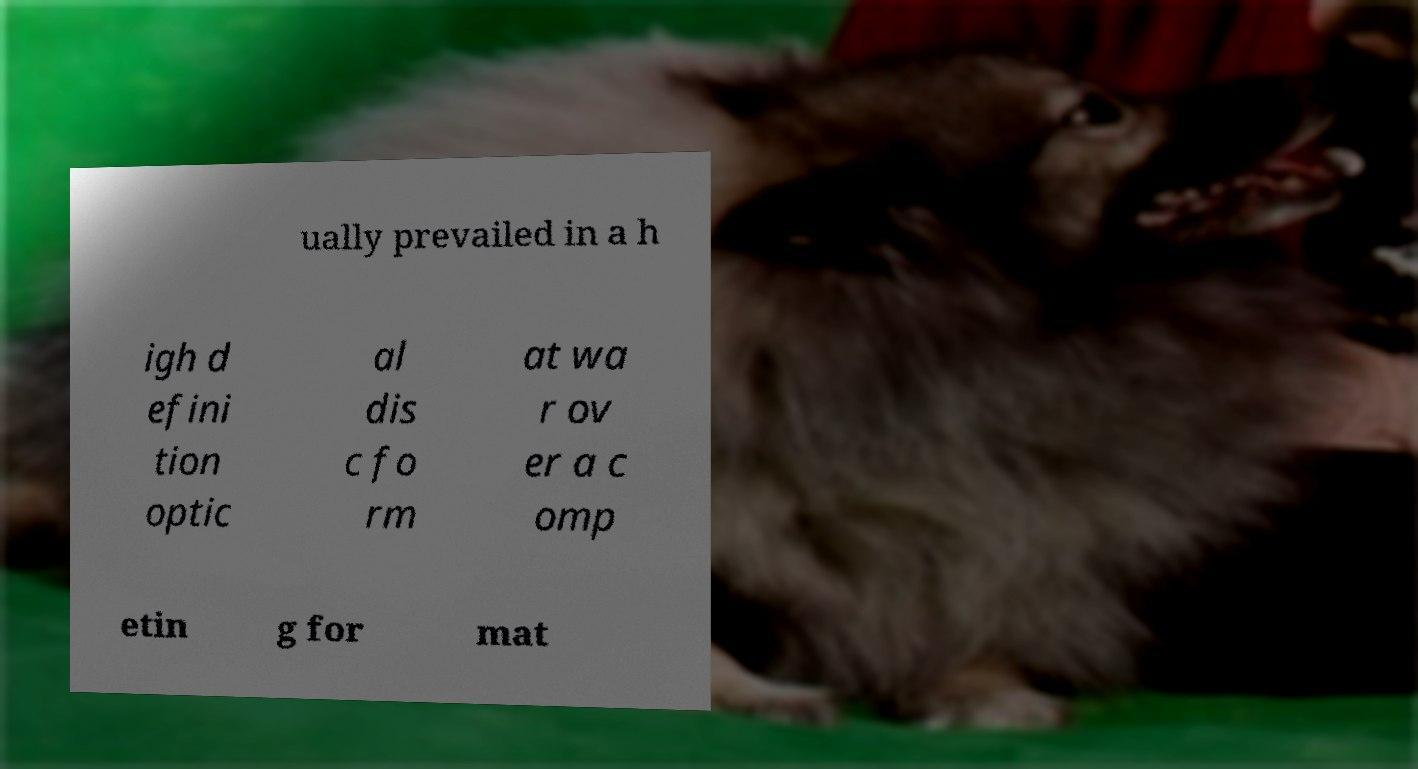Please read and relay the text visible in this image. What does it say? ually prevailed in a h igh d efini tion optic al dis c fo rm at wa r ov er a c omp etin g for mat 